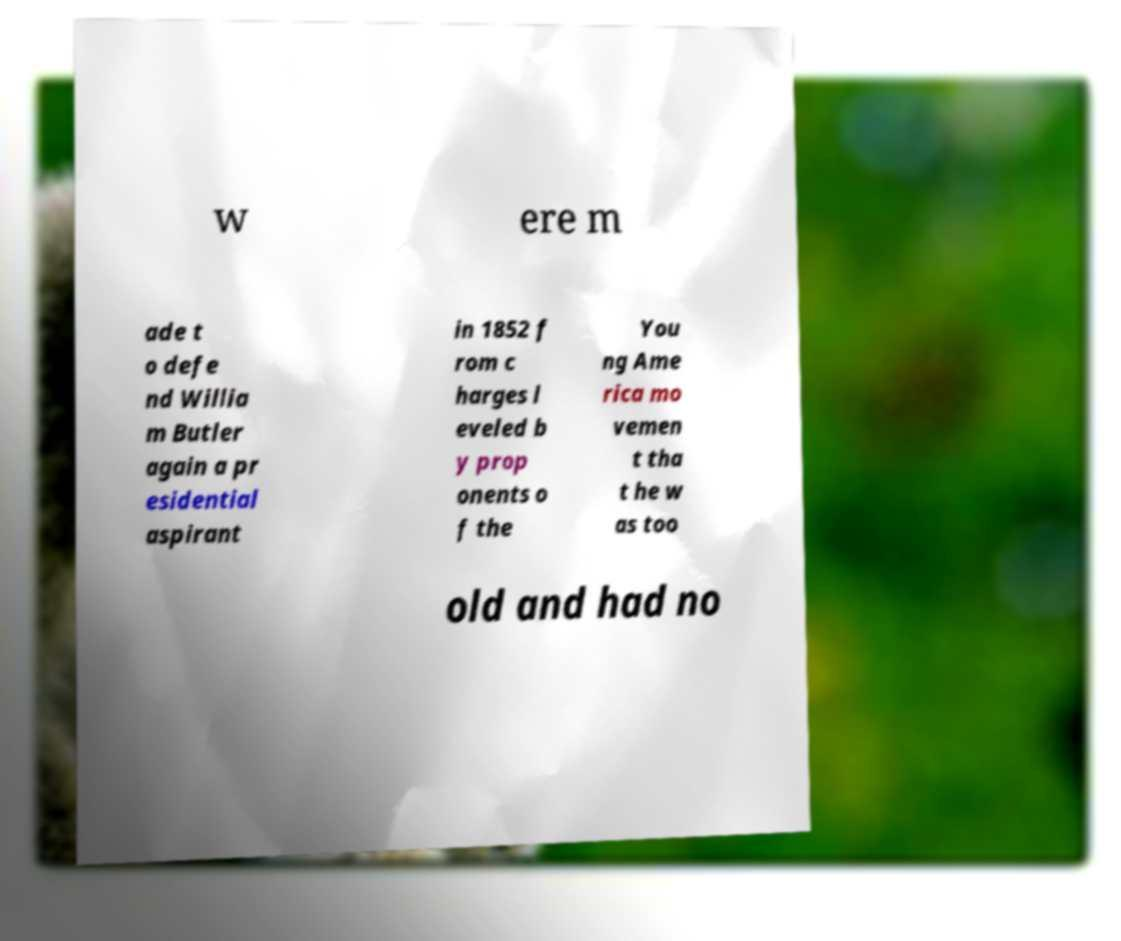Could you assist in decoding the text presented in this image and type it out clearly? w ere m ade t o defe nd Willia m Butler again a pr esidential aspirant in 1852 f rom c harges l eveled b y prop onents o f the You ng Ame rica mo vemen t tha t he w as too old and had no 